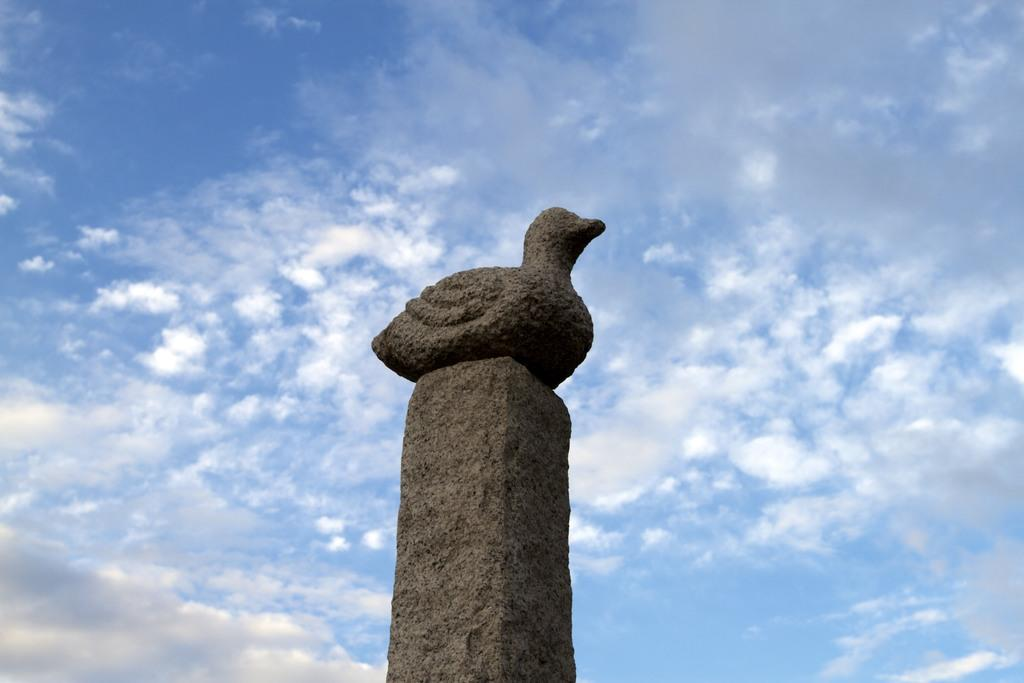What is the main subject of the image? The main subject of the image is a statue of a bird on a pole. Where is the statue located in the image? The statue is in the middle of the image. What can be seen in the background of the image? There are clouds in the background of the image. What color is the sky in the image? The sky is blue in the image. What type of dinner is being served in the image? There is no dinner present in the image; it features a statue of a bird on a pole. What type of coat is the bird wearing in the image? The bird is a statue and does not have a coat. 